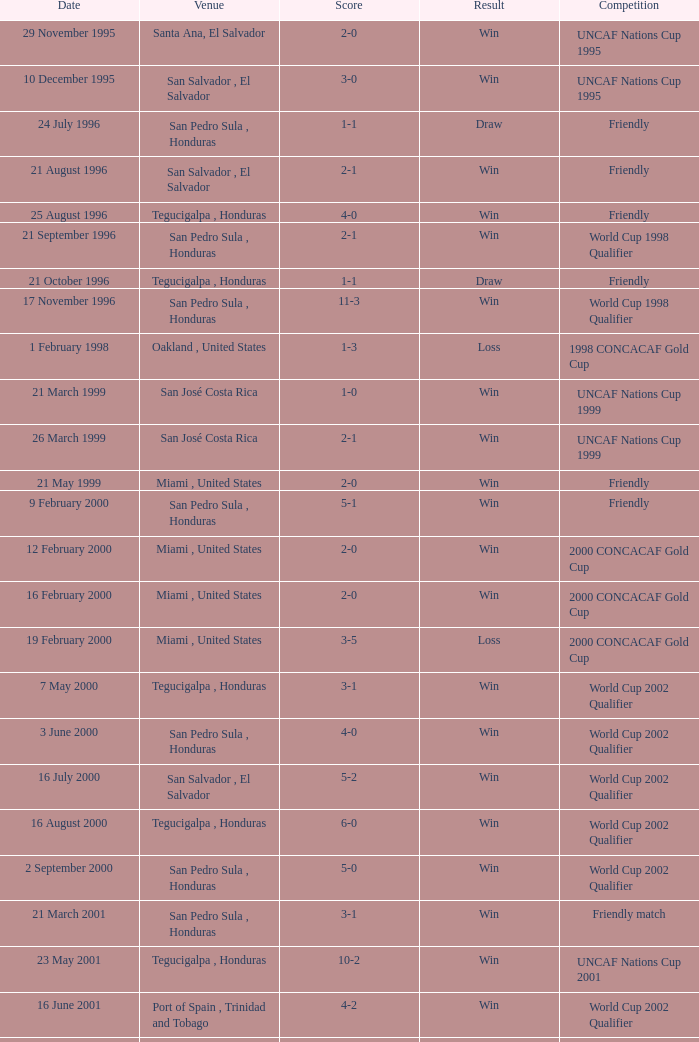Can you provide the score for may 7th, 2000? 3-1. 